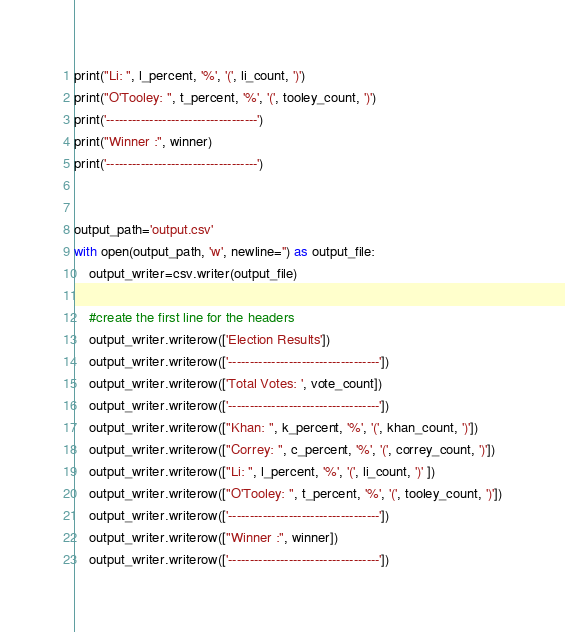Convert code to text. <code><loc_0><loc_0><loc_500><loc_500><_Python_>print("Li: ", l_percent, '%', '(', li_count, ')')
print("O'Tooley: ", t_percent, '%', '(', tooley_count, ')')
print('-----------------------------------')
print("Winner :", winner)
print('-----------------------------------')


output_path='output.csv'
with open(output_path, 'w', newline='') as output_file:
    output_writer=csv.writer(output_file)

    #create the first line for the headers
    output_writer.writerow(['Election Results'])
    output_writer.writerow(['-----------------------------------'])
    output_writer.writerow(['Total Votes: ', vote_count])
    output_writer.writerow(['-----------------------------------'])
    output_writer.writerow(["Khan: ", k_percent, '%', '(', khan_count, ')'])
    output_writer.writerow(["Correy: ", c_percent, '%', '(', correy_count, ')'])
    output_writer.writerow(["Li: ", l_percent, '%', '(', li_count, ')' ])
    output_writer.writerow(["O'Tooley: ", t_percent, '%', '(', tooley_count, ')'])
    output_writer.writerow(['-----------------------------------'])
    output_writer.writerow(["Winner :", winner])
    output_writer.writerow(['-----------------------------------'])</code> 